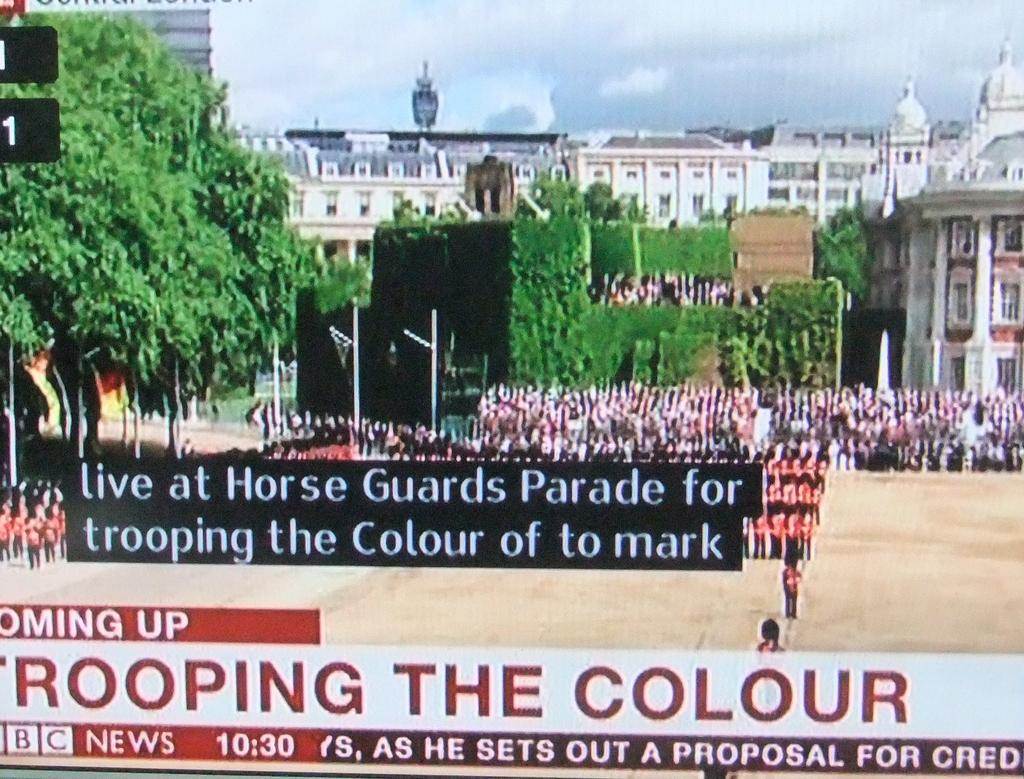How has the image been altered? The image has been edited. What can be found on the image besides the visual elements? There is text written on the image. What can be seen in the background of the image? There are persons, trees, buildings, and a cloudy sky in the background of the image. What type of pipe can be heard in the background of the image? There is no pipe or sound present in the image; it is a still image with text and visual elements. Can you describe the voice of the person in the image? There are no persons depicted in the image, only text and visual elements. 